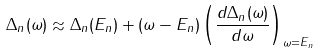<formula> <loc_0><loc_0><loc_500><loc_500>\Delta _ { n } ( \omega ) \approx \Delta _ { n } ( E _ { n } ) + ( \omega - E _ { n } ) \left ( \frac { d \Delta _ { n } ( \omega ) } { d \omega } \right ) _ { \omega = E _ { n } }</formula> 